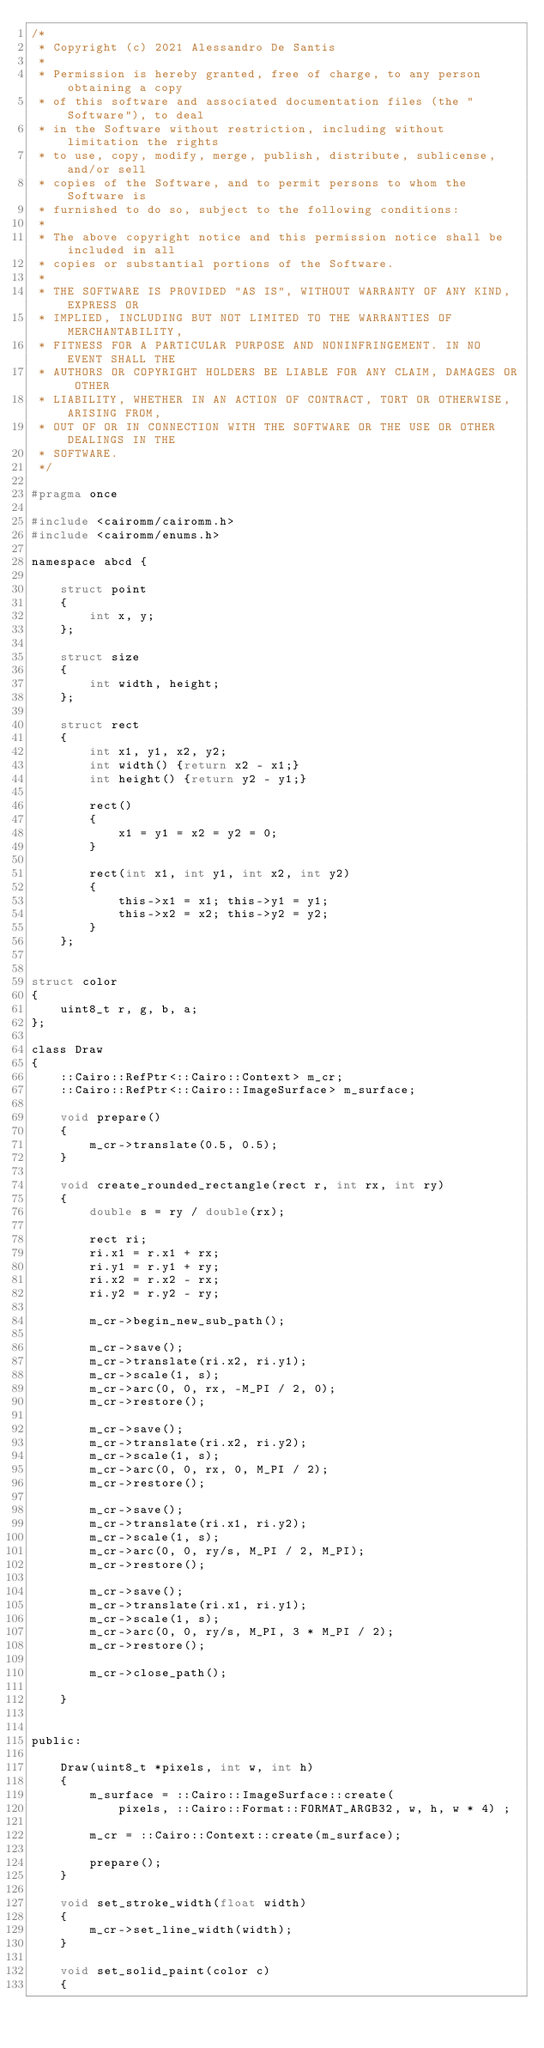<code> <loc_0><loc_0><loc_500><loc_500><_C_>/*
 * Copyright (c) 2021 Alessandro De Santis
 *
 * Permission is hereby granted, free of charge, to any person obtaining a copy
 * of this software and associated documentation files (the "Software"), to deal
 * in the Software without restriction, including without limitation the rights
 * to use, copy, modify, merge, publish, distribute, sublicense, and/or sell
 * copies of the Software, and to permit persons to whom the Software is
 * furnished to do so, subject to the following conditions:
 * 
 * The above copyright notice and this permission notice shall be included in all
 * copies or substantial portions of the Software.
 * 
 * THE SOFTWARE IS PROVIDED "AS IS", WITHOUT WARRANTY OF ANY KIND, EXPRESS OR
 * IMPLIED, INCLUDING BUT NOT LIMITED TO THE WARRANTIES OF MERCHANTABILITY,
 * FITNESS FOR A PARTICULAR PURPOSE AND NONINFRINGEMENT. IN NO EVENT SHALL THE
 * AUTHORS OR COPYRIGHT HOLDERS BE LIABLE FOR ANY CLAIM, DAMAGES OR OTHER
 * LIABILITY, WHETHER IN AN ACTION OF CONTRACT, TORT OR OTHERWISE, ARISING FROM,
 * OUT OF OR IN CONNECTION WITH THE SOFTWARE OR THE USE OR OTHER DEALINGS IN THE
 * SOFTWARE.
 */

#pragma once

#include <cairomm/cairomm.h>
#include <cairomm/enums.h>

namespace abcd {

	struct point
	{
		int x, y;
	};

	struct size
	{
		int width, height;
	};

	struct rect
	{
		int x1, y1, x2, y2;
		int width() {return x2 - x1;}
		int height() {return y2 - y1;}

		rect()
		{
			x1 = y1 = x2 = y2 = 0;
		}

		rect(int x1, int y1, int x2, int y2)
		{
			this->x1 = x1; this->y1 = y1; 
			this->x2 = x2; this->y2 = y2;
		}
	};


struct color
{
	uint8_t r, g, b, a;
};

class Draw
{
	::Cairo::RefPtr<::Cairo::Context> m_cr;
	::Cairo::RefPtr<::Cairo::ImageSurface> m_surface;

	void prepare()
	{
		m_cr->translate(0.5, 0.5);
	}

	void create_rounded_rectangle(rect r, int rx, int ry)
	{
		double s = ry / double(rx);

		rect ri;
		ri.x1 = r.x1 + rx;
		ri.y1 = r.y1 + ry;
		ri.x2 = r.x2 - rx;
		ri.y2 = r.y2 - ry;

		m_cr->begin_new_sub_path();

		m_cr->save();
		m_cr->translate(ri.x2, ri.y1);
		m_cr->scale(1, s);
		m_cr->arc(0, 0, rx, -M_PI / 2, 0);
		m_cr->restore();

		m_cr->save();
		m_cr->translate(ri.x2, ri.y2);
		m_cr->scale(1, s);
		m_cr->arc(0, 0, rx, 0, M_PI / 2);
		m_cr->restore();

		m_cr->save();
		m_cr->translate(ri.x1, ri.y2);
		m_cr->scale(1, s);
		m_cr->arc(0, 0, ry/s, M_PI / 2, M_PI);
		m_cr->restore();

		m_cr->save();
		m_cr->translate(ri.x1, ri.y1);
		m_cr->scale(1, s);
		m_cr->arc(0, 0, ry/s, M_PI, 3 * M_PI / 2);
		m_cr->restore();

		m_cr->close_path();

	}	


public:

	Draw(uint8_t *pixels, int w, int h)
	{
		m_surface = ::Cairo::ImageSurface::create(
			pixels, ::Cairo::Format::FORMAT_ARGB32, w, h, w * 4) ;

		m_cr = ::Cairo::Context::create(m_surface);

		prepare();
	}

	void set_stroke_width(float width)
	{
		m_cr->set_line_width(width);
	}

	void set_solid_paint(color c)
	{</code> 